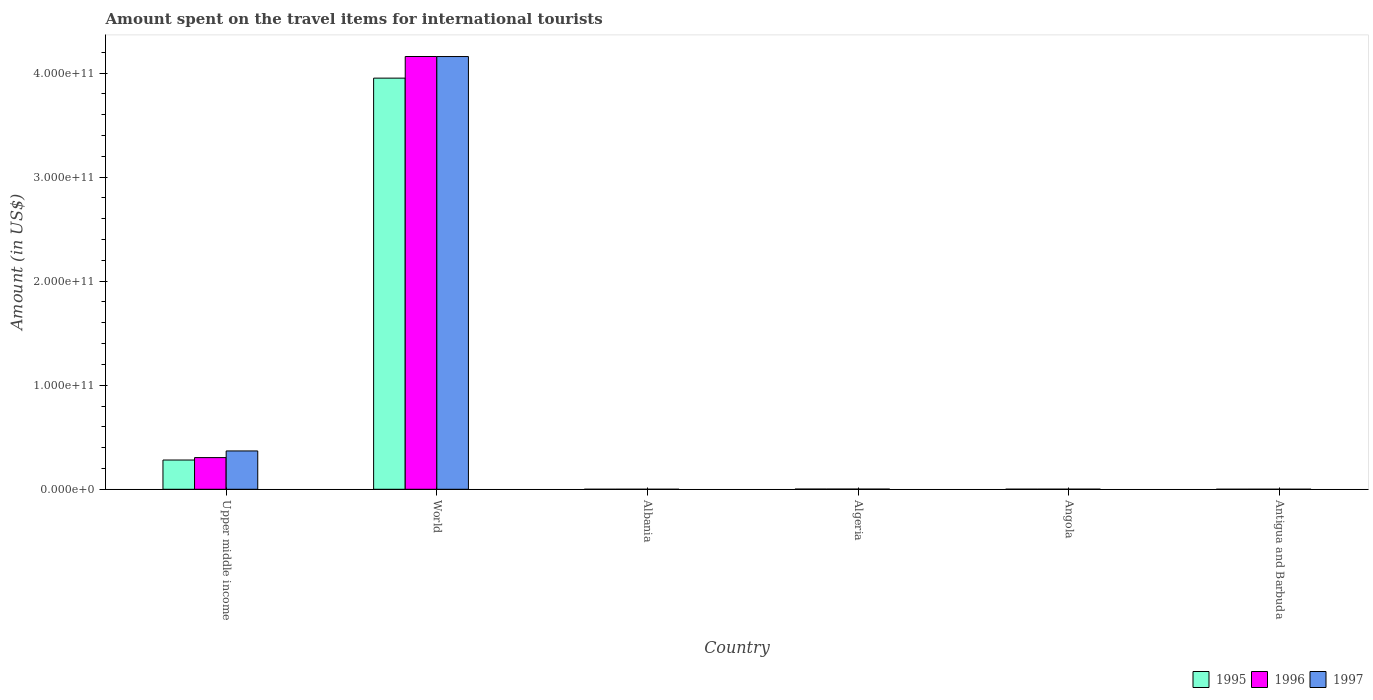Are the number of bars per tick equal to the number of legend labels?
Offer a terse response. Yes. How many bars are there on the 6th tick from the right?
Provide a succinct answer. 3. What is the label of the 1st group of bars from the left?
Offer a terse response. Upper middle income. In how many cases, is the number of bars for a given country not equal to the number of legend labels?
Provide a short and direct response. 0. What is the amount spent on the travel items for international tourists in 1996 in World?
Your response must be concise. 4.16e+11. Across all countries, what is the maximum amount spent on the travel items for international tourists in 1997?
Offer a terse response. 4.16e+11. Across all countries, what is the minimum amount spent on the travel items for international tourists in 1995?
Offer a terse response. 7.00e+06. In which country was the amount spent on the travel items for international tourists in 1996 maximum?
Your answer should be very brief. World. In which country was the amount spent on the travel items for international tourists in 1996 minimum?
Your answer should be compact. Albania. What is the total amount spent on the travel items for international tourists in 1995 in the graph?
Keep it short and to the point. 4.24e+11. What is the difference between the amount spent on the travel items for international tourists in 1997 in Albania and that in Antigua and Barbuda?
Give a very brief answer. -2.20e+07. What is the difference between the amount spent on the travel items for international tourists in 1997 in Albania and the amount spent on the travel items for international tourists in 1995 in Algeria?
Provide a short and direct response. -1.81e+08. What is the average amount spent on the travel items for international tourists in 1997 per country?
Your answer should be very brief. 7.55e+1. What is the difference between the amount spent on the travel items for international tourists of/in 1996 and amount spent on the travel items for international tourists of/in 1995 in Angola?
Your answer should be very brief. -2.00e+06. In how many countries, is the amount spent on the travel items for international tourists in 1995 greater than 260000000000 US$?
Offer a very short reply. 1. What is the ratio of the amount spent on the travel items for international tourists in 1997 in Angola to that in Upper middle income?
Your response must be concise. 0. What is the difference between the highest and the second highest amount spent on the travel items for international tourists in 1995?
Make the answer very short. -2.79e+1. What is the difference between the highest and the lowest amount spent on the travel items for international tourists in 1997?
Ensure brevity in your answer.  4.16e+11. In how many countries, is the amount spent on the travel items for international tourists in 1996 greater than the average amount spent on the travel items for international tourists in 1996 taken over all countries?
Keep it short and to the point. 1. What does the 2nd bar from the right in Albania represents?
Your answer should be very brief. 1996. Are all the bars in the graph horizontal?
Offer a very short reply. No. How many countries are there in the graph?
Keep it short and to the point. 6. What is the difference between two consecutive major ticks on the Y-axis?
Ensure brevity in your answer.  1.00e+11. Does the graph contain any zero values?
Give a very brief answer. No. Does the graph contain grids?
Ensure brevity in your answer.  No. What is the title of the graph?
Your answer should be very brief. Amount spent on the travel items for international tourists. What is the label or title of the Y-axis?
Make the answer very short. Amount (in US$). What is the Amount (in US$) in 1995 in Upper middle income?
Provide a short and direct response. 2.81e+1. What is the Amount (in US$) in 1996 in Upper middle income?
Your answer should be compact. 3.04e+1. What is the Amount (in US$) of 1997 in Upper middle income?
Your answer should be compact. 3.68e+1. What is the Amount (in US$) of 1995 in World?
Offer a very short reply. 3.95e+11. What is the Amount (in US$) of 1996 in World?
Provide a succinct answer. 4.16e+11. What is the Amount (in US$) in 1997 in World?
Make the answer very short. 4.16e+11. What is the Amount (in US$) in 1997 in Albania?
Provide a succinct answer. 5.00e+06. What is the Amount (in US$) of 1995 in Algeria?
Your answer should be very brief. 1.86e+08. What is the Amount (in US$) in 1996 in Algeria?
Ensure brevity in your answer.  1.88e+08. What is the Amount (in US$) of 1997 in Algeria?
Make the answer very short. 1.44e+08. What is the Amount (in US$) of 1995 in Angola?
Ensure brevity in your answer.  7.50e+07. What is the Amount (in US$) in 1996 in Angola?
Offer a very short reply. 7.30e+07. What is the Amount (in US$) in 1997 in Angola?
Make the answer very short. 9.80e+07. What is the Amount (in US$) in 1995 in Antigua and Barbuda?
Ensure brevity in your answer.  2.30e+07. What is the Amount (in US$) of 1996 in Antigua and Barbuda?
Provide a short and direct response. 2.60e+07. What is the Amount (in US$) in 1997 in Antigua and Barbuda?
Your answer should be very brief. 2.70e+07. Across all countries, what is the maximum Amount (in US$) of 1995?
Your response must be concise. 3.95e+11. Across all countries, what is the maximum Amount (in US$) in 1996?
Make the answer very short. 4.16e+11. Across all countries, what is the maximum Amount (in US$) of 1997?
Give a very brief answer. 4.16e+11. Across all countries, what is the minimum Amount (in US$) in 1995?
Provide a short and direct response. 7.00e+06. What is the total Amount (in US$) of 1995 in the graph?
Provide a short and direct response. 4.24e+11. What is the total Amount (in US$) in 1996 in the graph?
Provide a succinct answer. 4.47e+11. What is the total Amount (in US$) in 1997 in the graph?
Offer a very short reply. 4.53e+11. What is the difference between the Amount (in US$) of 1995 in Upper middle income and that in World?
Your response must be concise. -3.67e+11. What is the difference between the Amount (in US$) of 1996 in Upper middle income and that in World?
Your answer should be very brief. -3.85e+11. What is the difference between the Amount (in US$) of 1997 in Upper middle income and that in World?
Offer a very short reply. -3.79e+11. What is the difference between the Amount (in US$) in 1995 in Upper middle income and that in Albania?
Your response must be concise. 2.81e+1. What is the difference between the Amount (in US$) in 1996 in Upper middle income and that in Albania?
Provide a short and direct response. 3.04e+1. What is the difference between the Amount (in US$) in 1997 in Upper middle income and that in Albania?
Provide a short and direct response. 3.68e+1. What is the difference between the Amount (in US$) of 1995 in Upper middle income and that in Algeria?
Your answer should be compact. 2.79e+1. What is the difference between the Amount (in US$) of 1996 in Upper middle income and that in Algeria?
Ensure brevity in your answer.  3.03e+1. What is the difference between the Amount (in US$) in 1997 in Upper middle income and that in Algeria?
Your answer should be very brief. 3.67e+1. What is the difference between the Amount (in US$) in 1995 in Upper middle income and that in Angola?
Give a very brief answer. 2.80e+1. What is the difference between the Amount (in US$) of 1996 in Upper middle income and that in Angola?
Offer a very short reply. 3.04e+1. What is the difference between the Amount (in US$) of 1997 in Upper middle income and that in Angola?
Keep it short and to the point. 3.67e+1. What is the difference between the Amount (in US$) in 1995 in Upper middle income and that in Antigua and Barbuda?
Provide a short and direct response. 2.81e+1. What is the difference between the Amount (in US$) in 1996 in Upper middle income and that in Antigua and Barbuda?
Your response must be concise. 3.04e+1. What is the difference between the Amount (in US$) in 1997 in Upper middle income and that in Antigua and Barbuda?
Your answer should be compact. 3.68e+1. What is the difference between the Amount (in US$) in 1995 in World and that in Albania?
Your response must be concise. 3.95e+11. What is the difference between the Amount (in US$) of 1996 in World and that in Albania?
Your answer should be very brief. 4.16e+11. What is the difference between the Amount (in US$) in 1997 in World and that in Albania?
Keep it short and to the point. 4.16e+11. What is the difference between the Amount (in US$) in 1995 in World and that in Algeria?
Provide a succinct answer. 3.95e+11. What is the difference between the Amount (in US$) of 1996 in World and that in Algeria?
Offer a terse response. 4.16e+11. What is the difference between the Amount (in US$) in 1997 in World and that in Algeria?
Keep it short and to the point. 4.16e+11. What is the difference between the Amount (in US$) in 1995 in World and that in Angola?
Provide a short and direct response. 3.95e+11. What is the difference between the Amount (in US$) in 1996 in World and that in Angola?
Provide a succinct answer. 4.16e+11. What is the difference between the Amount (in US$) of 1997 in World and that in Angola?
Make the answer very short. 4.16e+11. What is the difference between the Amount (in US$) in 1995 in World and that in Antigua and Barbuda?
Your response must be concise. 3.95e+11. What is the difference between the Amount (in US$) of 1996 in World and that in Antigua and Barbuda?
Provide a succinct answer. 4.16e+11. What is the difference between the Amount (in US$) in 1997 in World and that in Antigua and Barbuda?
Offer a very short reply. 4.16e+11. What is the difference between the Amount (in US$) of 1995 in Albania and that in Algeria?
Give a very brief answer. -1.79e+08. What is the difference between the Amount (in US$) of 1996 in Albania and that in Algeria?
Keep it short and to the point. -1.76e+08. What is the difference between the Amount (in US$) in 1997 in Albania and that in Algeria?
Provide a short and direct response. -1.39e+08. What is the difference between the Amount (in US$) in 1995 in Albania and that in Angola?
Keep it short and to the point. -6.80e+07. What is the difference between the Amount (in US$) in 1996 in Albania and that in Angola?
Keep it short and to the point. -6.10e+07. What is the difference between the Amount (in US$) in 1997 in Albania and that in Angola?
Your response must be concise. -9.30e+07. What is the difference between the Amount (in US$) of 1995 in Albania and that in Antigua and Barbuda?
Make the answer very short. -1.60e+07. What is the difference between the Amount (in US$) in 1996 in Albania and that in Antigua and Barbuda?
Ensure brevity in your answer.  -1.40e+07. What is the difference between the Amount (in US$) in 1997 in Albania and that in Antigua and Barbuda?
Ensure brevity in your answer.  -2.20e+07. What is the difference between the Amount (in US$) of 1995 in Algeria and that in Angola?
Ensure brevity in your answer.  1.11e+08. What is the difference between the Amount (in US$) of 1996 in Algeria and that in Angola?
Provide a succinct answer. 1.15e+08. What is the difference between the Amount (in US$) of 1997 in Algeria and that in Angola?
Give a very brief answer. 4.60e+07. What is the difference between the Amount (in US$) in 1995 in Algeria and that in Antigua and Barbuda?
Your answer should be compact. 1.63e+08. What is the difference between the Amount (in US$) of 1996 in Algeria and that in Antigua and Barbuda?
Offer a very short reply. 1.62e+08. What is the difference between the Amount (in US$) of 1997 in Algeria and that in Antigua and Barbuda?
Provide a short and direct response. 1.17e+08. What is the difference between the Amount (in US$) in 1995 in Angola and that in Antigua and Barbuda?
Your answer should be compact. 5.20e+07. What is the difference between the Amount (in US$) of 1996 in Angola and that in Antigua and Barbuda?
Provide a succinct answer. 4.70e+07. What is the difference between the Amount (in US$) of 1997 in Angola and that in Antigua and Barbuda?
Your response must be concise. 7.10e+07. What is the difference between the Amount (in US$) in 1995 in Upper middle income and the Amount (in US$) in 1996 in World?
Provide a short and direct response. -3.88e+11. What is the difference between the Amount (in US$) of 1995 in Upper middle income and the Amount (in US$) of 1997 in World?
Offer a very short reply. -3.88e+11. What is the difference between the Amount (in US$) in 1996 in Upper middle income and the Amount (in US$) in 1997 in World?
Provide a succinct answer. -3.85e+11. What is the difference between the Amount (in US$) of 1995 in Upper middle income and the Amount (in US$) of 1996 in Albania?
Provide a short and direct response. 2.81e+1. What is the difference between the Amount (in US$) in 1995 in Upper middle income and the Amount (in US$) in 1997 in Albania?
Your answer should be very brief. 2.81e+1. What is the difference between the Amount (in US$) of 1996 in Upper middle income and the Amount (in US$) of 1997 in Albania?
Your answer should be very brief. 3.04e+1. What is the difference between the Amount (in US$) in 1995 in Upper middle income and the Amount (in US$) in 1996 in Algeria?
Your response must be concise. 2.79e+1. What is the difference between the Amount (in US$) in 1995 in Upper middle income and the Amount (in US$) in 1997 in Algeria?
Provide a short and direct response. 2.80e+1. What is the difference between the Amount (in US$) in 1996 in Upper middle income and the Amount (in US$) in 1997 in Algeria?
Your response must be concise. 3.03e+1. What is the difference between the Amount (in US$) of 1995 in Upper middle income and the Amount (in US$) of 1996 in Angola?
Your answer should be compact. 2.80e+1. What is the difference between the Amount (in US$) of 1995 in Upper middle income and the Amount (in US$) of 1997 in Angola?
Offer a very short reply. 2.80e+1. What is the difference between the Amount (in US$) of 1996 in Upper middle income and the Amount (in US$) of 1997 in Angola?
Offer a very short reply. 3.03e+1. What is the difference between the Amount (in US$) in 1995 in Upper middle income and the Amount (in US$) in 1996 in Antigua and Barbuda?
Give a very brief answer. 2.81e+1. What is the difference between the Amount (in US$) of 1995 in Upper middle income and the Amount (in US$) of 1997 in Antigua and Barbuda?
Offer a terse response. 2.81e+1. What is the difference between the Amount (in US$) of 1996 in Upper middle income and the Amount (in US$) of 1997 in Antigua and Barbuda?
Your answer should be very brief. 3.04e+1. What is the difference between the Amount (in US$) in 1995 in World and the Amount (in US$) in 1996 in Albania?
Your answer should be very brief. 3.95e+11. What is the difference between the Amount (in US$) in 1995 in World and the Amount (in US$) in 1997 in Albania?
Your response must be concise. 3.95e+11. What is the difference between the Amount (in US$) of 1996 in World and the Amount (in US$) of 1997 in Albania?
Provide a succinct answer. 4.16e+11. What is the difference between the Amount (in US$) of 1995 in World and the Amount (in US$) of 1996 in Algeria?
Your answer should be very brief. 3.95e+11. What is the difference between the Amount (in US$) of 1995 in World and the Amount (in US$) of 1997 in Algeria?
Offer a terse response. 3.95e+11. What is the difference between the Amount (in US$) in 1996 in World and the Amount (in US$) in 1997 in Algeria?
Give a very brief answer. 4.16e+11. What is the difference between the Amount (in US$) in 1995 in World and the Amount (in US$) in 1996 in Angola?
Provide a short and direct response. 3.95e+11. What is the difference between the Amount (in US$) of 1995 in World and the Amount (in US$) of 1997 in Angola?
Offer a terse response. 3.95e+11. What is the difference between the Amount (in US$) in 1996 in World and the Amount (in US$) in 1997 in Angola?
Provide a short and direct response. 4.16e+11. What is the difference between the Amount (in US$) in 1995 in World and the Amount (in US$) in 1996 in Antigua and Barbuda?
Your response must be concise. 3.95e+11. What is the difference between the Amount (in US$) of 1995 in World and the Amount (in US$) of 1997 in Antigua and Barbuda?
Provide a short and direct response. 3.95e+11. What is the difference between the Amount (in US$) of 1996 in World and the Amount (in US$) of 1997 in Antigua and Barbuda?
Provide a succinct answer. 4.16e+11. What is the difference between the Amount (in US$) of 1995 in Albania and the Amount (in US$) of 1996 in Algeria?
Your answer should be compact. -1.81e+08. What is the difference between the Amount (in US$) of 1995 in Albania and the Amount (in US$) of 1997 in Algeria?
Provide a short and direct response. -1.37e+08. What is the difference between the Amount (in US$) in 1996 in Albania and the Amount (in US$) in 1997 in Algeria?
Provide a short and direct response. -1.32e+08. What is the difference between the Amount (in US$) in 1995 in Albania and the Amount (in US$) in 1996 in Angola?
Make the answer very short. -6.60e+07. What is the difference between the Amount (in US$) of 1995 in Albania and the Amount (in US$) of 1997 in Angola?
Provide a succinct answer. -9.10e+07. What is the difference between the Amount (in US$) of 1996 in Albania and the Amount (in US$) of 1997 in Angola?
Offer a terse response. -8.60e+07. What is the difference between the Amount (in US$) in 1995 in Albania and the Amount (in US$) in 1996 in Antigua and Barbuda?
Provide a succinct answer. -1.90e+07. What is the difference between the Amount (in US$) in 1995 in Albania and the Amount (in US$) in 1997 in Antigua and Barbuda?
Provide a short and direct response. -2.00e+07. What is the difference between the Amount (in US$) in 1996 in Albania and the Amount (in US$) in 1997 in Antigua and Barbuda?
Give a very brief answer. -1.50e+07. What is the difference between the Amount (in US$) of 1995 in Algeria and the Amount (in US$) of 1996 in Angola?
Offer a terse response. 1.13e+08. What is the difference between the Amount (in US$) of 1995 in Algeria and the Amount (in US$) of 1997 in Angola?
Offer a terse response. 8.80e+07. What is the difference between the Amount (in US$) in 1996 in Algeria and the Amount (in US$) in 1997 in Angola?
Offer a very short reply. 9.00e+07. What is the difference between the Amount (in US$) of 1995 in Algeria and the Amount (in US$) of 1996 in Antigua and Barbuda?
Keep it short and to the point. 1.60e+08. What is the difference between the Amount (in US$) in 1995 in Algeria and the Amount (in US$) in 1997 in Antigua and Barbuda?
Make the answer very short. 1.59e+08. What is the difference between the Amount (in US$) in 1996 in Algeria and the Amount (in US$) in 1997 in Antigua and Barbuda?
Offer a terse response. 1.61e+08. What is the difference between the Amount (in US$) of 1995 in Angola and the Amount (in US$) of 1996 in Antigua and Barbuda?
Offer a very short reply. 4.90e+07. What is the difference between the Amount (in US$) in 1995 in Angola and the Amount (in US$) in 1997 in Antigua and Barbuda?
Ensure brevity in your answer.  4.80e+07. What is the difference between the Amount (in US$) in 1996 in Angola and the Amount (in US$) in 1997 in Antigua and Barbuda?
Your response must be concise. 4.60e+07. What is the average Amount (in US$) of 1995 per country?
Your answer should be very brief. 7.06e+1. What is the average Amount (in US$) in 1996 per country?
Your answer should be compact. 7.44e+1. What is the average Amount (in US$) in 1997 per country?
Offer a terse response. 7.55e+1. What is the difference between the Amount (in US$) of 1995 and Amount (in US$) of 1996 in Upper middle income?
Offer a terse response. -2.34e+09. What is the difference between the Amount (in US$) of 1995 and Amount (in US$) of 1997 in Upper middle income?
Provide a short and direct response. -8.72e+09. What is the difference between the Amount (in US$) in 1996 and Amount (in US$) in 1997 in Upper middle income?
Offer a very short reply. -6.39e+09. What is the difference between the Amount (in US$) of 1995 and Amount (in US$) of 1996 in World?
Make the answer very short. -2.08e+1. What is the difference between the Amount (in US$) in 1995 and Amount (in US$) in 1997 in World?
Give a very brief answer. -2.08e+1. What is the difference between the Amount (in US$) in 1996 and Amount (in US$) in 1997 in World?
Provide a succinct answer. 1.91e+07. What is the difference between the Amount (in US$) in 1995 and Amount (in US$) in 1996 in Albania?
Offer a terse response. -5.00e+06. What is the difference between the Amount (in US$) in 1995 and Amount (in US$) in 1997 in Albania?
Provide a succinct answer. 2.00e+06. What is the difference between the Amount (in US$) in 1996 and Amount (in US$) in 1997 in Albania?
Offer a very short reply. 7.00e+06. What is the difference between the Amount (in US$) in 1995 and Amount (in US$) in 1996 in Algeria?
Your response must be concise. -2.00e+06. What is the difference between the Amount (in US$) in 1995 and Amount (in US$) in 1997 in Algeria?
Provide a succinct answer. 4.20e+07. What is the difference between the Amount (in US$) in 1996 and Amount (in US$) in 1997 in Algeria?
Provide a short and direct response. 4.40e+07. What is the difference between the Amount (in US$) of 1995 and Amount (in US$) of 1997 in Angola?
Offer a terse response. -2.30e+07. What is the difference between the Amount (in US$) of 1996 and Amount (in US$) of 1997 in Angola?
Provide a short and direct response. -2.50e+07. What is the difference between the Amount (in US$) in 1995 and Amount (in US$) in 1997 in Antigua and Barbuda?
Provide a succinct answer. -4.00e+06. What is the difference between the Amount (in US$) in 1996 and Amount (in US$) in 1997 in Antigua and Barbuda?
Offer a very short reply. -1.00e+06. What is the ratio of the Amount (in US$) in 1995 in Upper middle income to that in World?
Ensure brevity in your answer.  0.07. What is the ratio of the Amount (in US$) in 1996 in Upper middle income to that in World?
Ensure brevity in your answer.  0.07. What is the ratio of the Amount (in US$) in 1997 in Upper middle income to that in World?
Provide a succinct answer. 0.09. What is the ratio of the Amount (in US$) in 1995 in Upper middle income to that in Albania?
Give a very brief answer. 4015.88. What is the ratio of the Amount (in US$) in 1996 in Upper middle income to that in Albania?
Give a very brief answer. 2537.19. What is the ratio of the Amount (in US$) of 1997 in Upper middle income to that in Albania?
Offer a terse response. 7367.01. What is the ratio of the Amount (in US$) of 1995 in Upper middle income to that in Algeria?
Your answer should be very brief. 151.14. What is the ratio of the Amount (in US$) in 1996 in Upper middle income to that in Algeria?
Give a very brief answer. 161.95. What is the ratio of the Amount (in US$) in 1997 in Upper middle income to that in Algeria?
Ensure brevity in your answer.  255.8. What is the ratio of the Amount (in US$) of 1995 in Upper middle income to that in Angola?
Give a very brief answer. 374.82. What is the ratio of the Amount (in US$) in 1996 in Upper middle income to that in Angola?
Keep it short and to the point. 417.07. What is the ratio of the Amount (in US$) in 1997 in Upper middle income to that in Angola?
Offer a very short reply. 375.87. What is the ratio of the Amount (in US$) of 1995 in Upper middle income to that in Antigua and Barbuda?
Your answer should be very brief. 1222.22. What is the ratio of the Amount (in US$) of 1996 in Upper middle income to that in Antigua and Barbuda?
Offer a very short reply. 1171.01. What is the ratio of the Amount (in US$) of 1997 in Upper middle income to that in Antigua and Barbuda?
Offer a terse response. 1364.26. What is the ratio of the Amount (in US$) in 1995 in World to that in Albania?
Offer a very short reply. 5.64e+04. What is the ratio of the Amount (in US$) of 1996 in World to that in Albania?
Your answer should be very brief. 3.47e+04. What is the ratio of the Amount (in US$) of 1997 in World to that in Albania?
Provide a short and direct response. 8.32e+04. What is the ratio of the Amount (in US$) in 1995 in World to that in Algeria?
Offer a very short reply. 2124.35. What is the ratio of the Amount (in US$) of 1996 in World to that in Algeria?
Provide a short and direct response. 2212.28. What is the ratio of the Amount (in US$) of 1997 in World to that in Algeria?
Give a very brief answer. 2888.12. What is the ratio of the Amount (in US$) in 1995 in World to that in Angola?
Provide a short and direct response. 5268.38. What is the ratio of the Amount (in US$) of 1996 in World to that in Angola?
Provide a short and direct response. 5697.38. What is the ratio of the Amount (in US$) in 1997 in World to that in Angola?
Offer a very short reply. 4243.77. What is the ratio of the Amount (in US$) of 1995 in World to that in Antigua and Barbuda?
Your response must be concise. 1.72e+04. What is the ratio of the Amount (in US$) of 1996 in World to that in Antigua and Barbuda?
Make the answer very short. 1.60e+04. What is the ratio of the Amount (in US$) of 1997 in World to that in Antigua and Barbuda?
Your answer should be very brief. 1.54e+04. What is the ratio of the Amount (in US$) in 1995 in Albania to that in Algeria?
Keep it short and to the point. 0.04. What is the ratio of the Amount (in US$) in 1996 in Albania to that in Algeria?
Your response must be concise. 0.06. What is the ratio of the Amount (in US$) of 1997 in Albania to that in Algeria?
Provide a short and direct response. 0.03. What is the ratio of the Amount (in US$) of 1995 in Albania to that in Angola?
Keep it short and to the point. 0.09. What is the ratio of the Amount (in US$) of 1996 in Albania to that in Angola?
Provide a succinct answer. 0.16. What is the ratio of the Amount (in US$) of 1997 in Albania to that in Angola?
Your response must be concise. 0.05. What is the ratio of the Amount (in US$) in 1995 in Albania to that in Antigua and Barbuda?
Your response must be concise. 0.3. What is the ratio of the Amount (in US$) in 1996 in Albania to that in Antigua and Barbuda?
Ensure brevity in your answer.  0.46. What is the ratio of the Amount (in US$) of 1997 in Albania to that in Antigua and Barbuda?
Ensure brevity in your answer.  0.19. What is the ratio of the Amount (in US$) of 1995 in Algeria to that in Angola?
Make the answer very short. 2.48. What is the ratio of the Amount (in US$) of 1996 in Algeria to that in Angola?
Provide a short and direct response. 2.58. What is the ratio of the Amount (in US$) of 1997 in Algeria to that in Angola?
Keep it short and to the point. 1.47. What is the ratio of the Amount (in US$) in 1995 in Algeria to that in Antigua and Barbuda?
Provide a succinct answer. 8.09. What is the ratio of the Amount (in US$) in 1996 in Algeria to that in Antigua and Barbuda?
Make the answer very short. 7.23. What is the ratio of the Amount (in US$) of 1997 in Algeria to that in Antigua and Barbuda?
Your answer should be very brief. 5.33. What is the ratio of the Amount (in US$) in 1995 in Angola to that in Antigua and Barbuda?
Offer a terse response. 3.26. What is the ratio of the Amount (in US$) in 1996 in Angola to that in Antigua and Barbuda?
Give a very brief answer. 2.81. What is the ratio of the Amount (in US$) of 1997 in Angola to that in Antigua and Barbuda?
Offer a very short reply. 3.63. What is the difference between the highest and the second highest Amount (in US$) in 1995?
Make the answer very short. 3.67e+11. What is the difference between the highest and the second highest Amount (in US$) of 1996?
Offer a terse response. 3.85e+11. What is the difference between the highest and the second highest Amount (in US$) of 1997?
Give a very brief answer. 3.79e+11. What is the difference between the highest and the lowest Amount (in US$) of 1995?
Your answer should be very brief. 3.95e+11. What is the difference between the highest and the lowest Amount (in US$) in 1996?
Offer a terse response. 4.16e+11. What is the difference between the highest and the lowest Amount (in US$) in 1997?
Make the answer very short. 4.16e+11. 